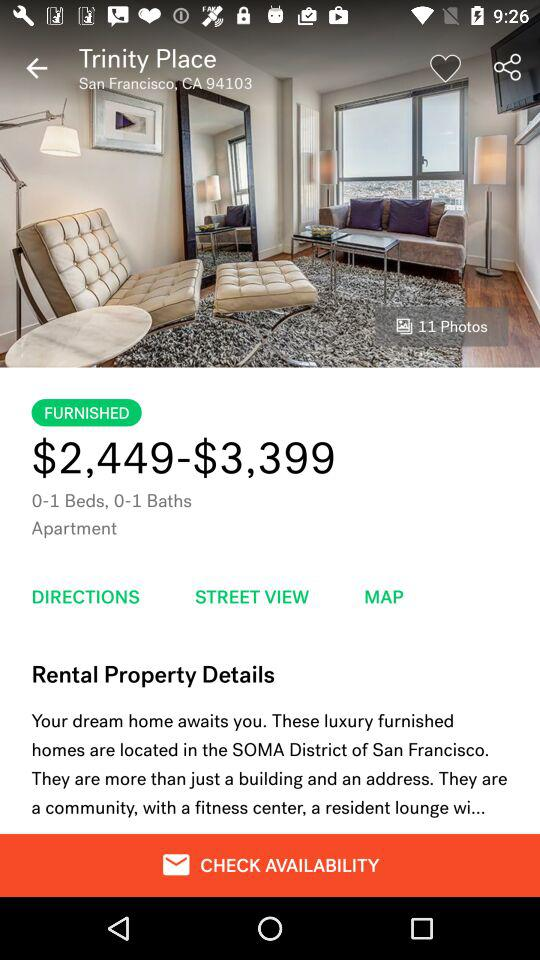What is the location of the Trinity Place apartment? The location is the SOMA District of San Francisco. 